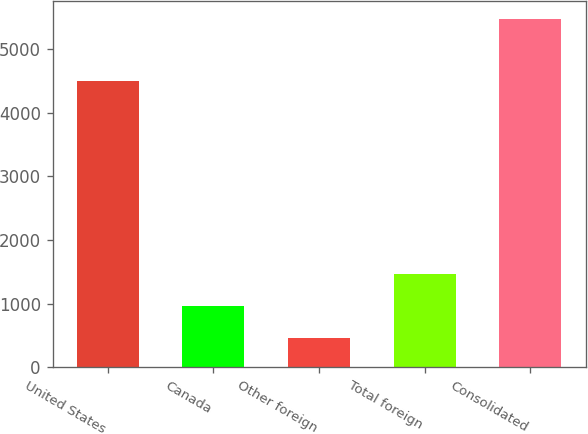Convert chart to OTSL. <chart><loc_0><loc_0><loc_500><loc_500><bar_chart><fcel>United States<fcel>Canada<fcel>Other foreign<fcel>Total foreign<fcel>Consolidated<nl><fcel>4497.8<fcel>969.03<fcel>468.4<fcel>1469.66<fcel>5474.7<nl></chart> 